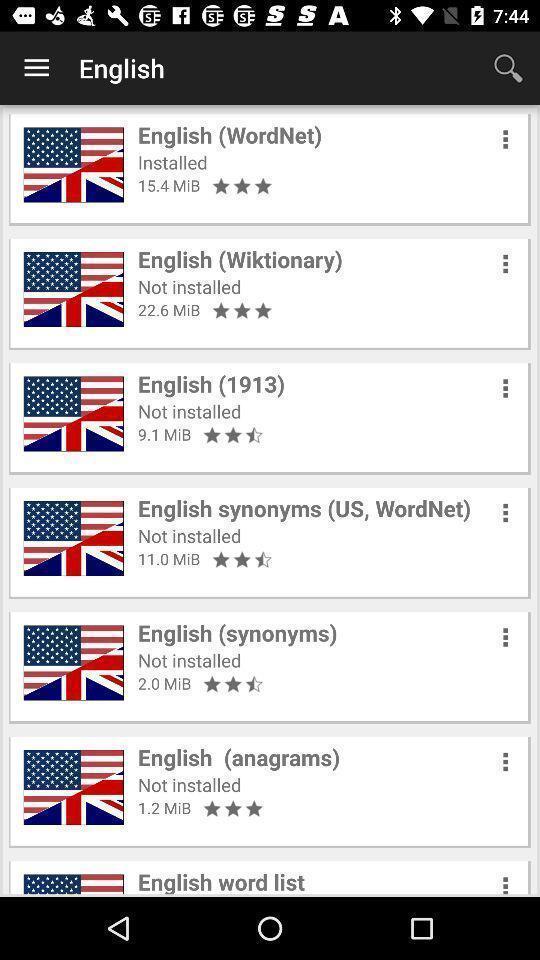Describe the visual elements of this screenshot. Screen displaying the list of options in a dictionary page. 